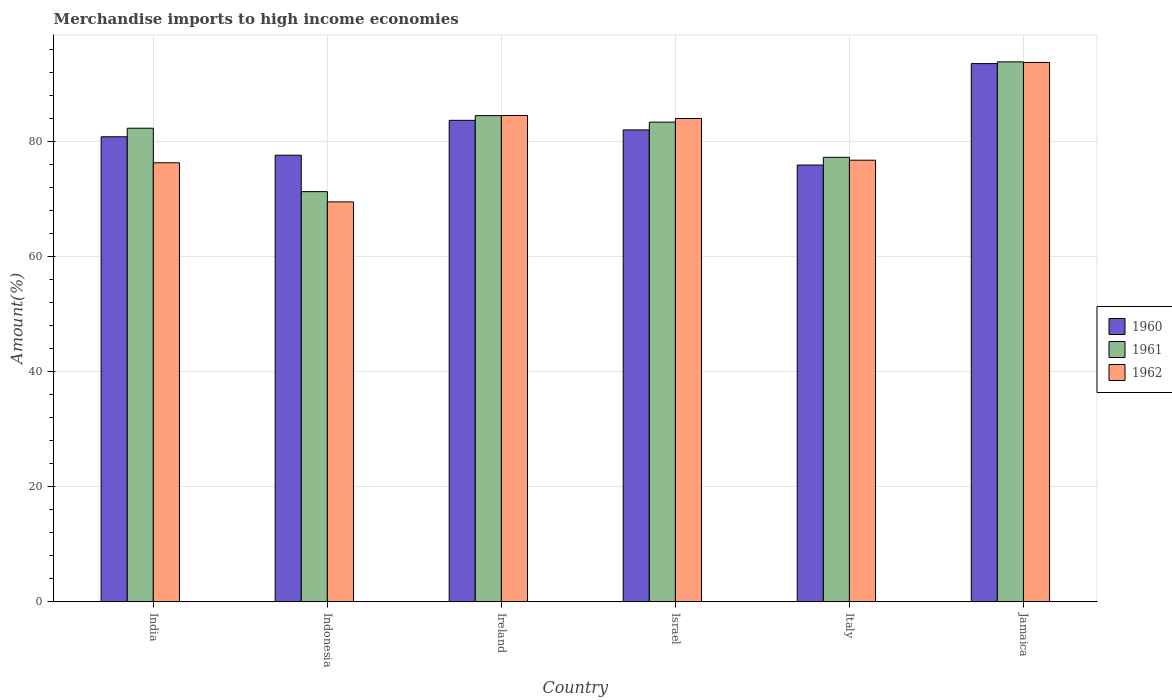How many different coloured bars are there?
Make the answer very short. 3. Are the number of bars per tick equal to the number of legend labels?
Ensure brevity in your answer.  Yes. How many bars are there on the 4th tick from the left?
Ensure brevity in your answer.  3. How many bars are there on the 4th tick from the right?
Offer a terse response. 3. What is the label of the 3rd group of bars from the left?
Provide a succinct answer. Ireland. In how many cases, is the number of bars for a given country not equal to the number of legend labels?
Ensure brevity in your answer.  0. What is the percentage of amount earned from merchandise imports in 1962 in Ireland?
Offer a terse response. 84.51. Across all countries, what is the maximum percentage of amount earned from merchandise imports in 1962?
Your answer should be compact. 93.72. Across all countries, what is the minimum percentage of amount earned from merchandise imports in 1960?
Your answer should be very brief. 75.9. In which country was the percentage of amount earned from merchandise imports in 1962 maximum?
Offer a terse response. Jamaica. What is the total percentage of amount earned from merchandise imports in 1961 in the graph?
Your response must be concise. 492.46. What is the difference between the percentage of amount earned from merchandise imports in 1960 in Israel and that in Italy?
Make the answer very short. 6.1. What is the difference between the percentage of amount earned from merchandise imports in 1962 in India and the percentage of amount earned from merchandise imports in 1960 in Jamaica?
Your response must be concise. -17.23. What is the average percentage of amount earned from merchandise imports in 1961 per country?
Provide a short and direct response. 82.08. What is the difference between the percentage of amount earned from merchandise imports of/in 1961 and percentage of amount earned from merchandise imports of/in 1962 in India?
Your response must be concise. 6. What is the ratio of the percentage of amount earned from merchandise imports in 1961 in Indonesia to that in Italy?
Provide a succinct answer. 0.92. What is the difference between the highest and the second highest percentage of amount earned from merchandise imports in 1962?
Offer a terse response. -0.52. What is the difference between the highest and the lowest percentage of amount earned from merchandise imports in 1962?
Offer a terse response. 24.22. In how many countries, is the percentage of amount earned from merchandise imports in 1960 greater than the average percentage of amount earned from merchandise imports in 1960 taken over all countries?
Offer a terse response. 2. Is the sum of the percentage of amount earned from merchandise imports in 1960 in India and Ireland greater than the maximum percentage of amount earned from merchandise imports in 1962 across all countries?
Your answer should be very brief. Yes. What does the 3rd bar from the left in Ireland represents?
Provide a short and direct response. 1962. What does the 3rd bar from the right in Indonesia represents?
Your answer should be very brief. 1960. How many countries are there in the graph?
Offer a very short reply. 6. Where does the legend appear in the graph?
Your answer should be compact. Center right. What is the title of the graph?
Keep it short and to the point. Merchandise imports to high income economies. Does "1972" appear as one of the legend labels in the graph?
Make the answer very short. No. What is the label or title of the Y-axis?
Keep it short and to the point. Amount(%). What is the Amount(%) of 1960 in India?
Your answer should be very brief. 80.81. What is the Amount(%) in 1961 in India?
Provide a succinct answer. 82.29. What is the Amount(%) of 1962 in India?
Make the answer very short. 76.29. What is the Amount(%) in 1960 in Indonesia?
Your answer should be compact. 77.61. What is the Amount(%) of 1961 in Indonesia?
Provide a short and direct response. 71.28. What is the Amount(%) of 1962 in Indonesia?
Make the answer very short. 69.5. What is the Amount(%) in 1960 in Ireland?
Make the answer very short. 83.66. What is the Amount(%) in 1961 in Ireland?
Offer a terse response. 84.48. What is the Amount(%) in 1962 in Ireland?
Provide a short and direct response. 84.51. What is the Amount(%) in 1960 in Israel?
Give a very brief answer. 82. What is the Amount(%) in 1961 in Israel?
Provide a short and direct response. 83.35. What is the Amount(%) of 1962 in Israel?
Provide a short and direct response. 83.98. What is the Amount(%) of 1960 in Italy?
Offer a terse response. 75.9. What is the Amount(%) in 1961 in Italy?
Offer a terse response. 77.24. What is the Amount(%) in 1962 in Italy?
Your answer should be very brief. 76.74. What is the Amount(%) in 1960 in Jamaica?
Your answer should be compact. 93.52. What is the Amount(%) of 1961 in Jamaica?
Your answer should be very brief. 93.82. What is the Amount(%) in 1962 in Jamaica?
Provide a succinct answer. 93.72. Across all countries, what is the maximum Amount(%) of 1960?
Keep it short and to the point. 93.52. Across all countries, what is the maximum Amount(%) of 1961?
Keep it short and to the point. 93.82. Across all countries, what is the maximum Amount(%) of 1962?
Provide a short and direct response. 93.72. Across all countries, what is the minimum Amount(%) of 1960?
Your answer should be very brief. 75.9. Across all countries, what is the minimum Amount(%) in 1961?
Your answer should be compact. 71.28. Across all countries, what is the minimum Amount(%) of 1962?
Your answer should be compact. 69.5. What is the total Amount(%) of 1960 in the graph?
Make the answer very short. 493.5. What is the total Amount(%) of 1961 in the graph?
Ensure brevity in your answer.  492.46. What is the total Amount(%) in 1962 in the graph?
Give a very brief answer. 484.74. What is the difference between the Amount(%) in 1960 in India and that in Indonesia?
Your answer should be very brief. 3.2. What is the difference between the Amount(%) of 1961 in India and that in Indonesia?
Make the answer very short. 11.02. What is the difference between the Amount(%) in 1962 in India and that in Indonesia?
Provide a short and direct response. 6.8. What is the difference between the Amount(%) of 1960 in India and that in Ireland?
Give a very brief answer. -2.86. What is the difference between the Amount(%) in 1961 in India and that in Ireland?
Make the answer very short. -2.19. What is the difference between the Amount(%) of 1962 in India and that in Ireland?
Offer a terse response. -8.21. What is the difference between the Amount(%) in 1960 in India and that in Israel?
Your answer should be compact. -1.19. What is the difference between the Amount(%) of 1961 in India and that in Israel?
Provide a short and direct response. -1.05. What is the difference between the Amount(%) of 1962 in India and that in Israel?
Your response must be concise. -7.69. What is the difference between the Amount(%) of 1960 in India and that in Italy?
Offer a very short reply. 4.91. What is the difference between the Amount(%) of 1961 in India and that in Italy?
Provide a succinct answer. 5.06. What is the difference between the Amount(%) of 1962 in India and that in Italy?
Your answer should be very brief. -0.45. What is the difference between the Amount(%) of 1960 in India and that in Jamaica?
Your answer should be compact. -12.71. What is the difference between the Amount(%) in 1961 in India and that in Jamaica?
Give a very brief answer. -11.53. What is the difference between the Amount(%) in 1962 in India and that in Jamaica?
Your answer should be very brief. -17.43. What is the difference between the Amount(%) of 1960 in Indonesia and that in Ireland?
Ensure brevity in your answer.  -6.06. What is the difference between the Amount(%) of 1961 in Indonesia and that in Ireland?
Provide a short and direct response. -13.21. What is the difference between the Amount(%) of 1962 in Indonesia and that in Ireland?
Your answer should be very brief. -15.01. What is the difference between the Amount(%) in 1960 in Indonesia and that in Israel?
Provide a short and direct response. -4.39. What is the difference between the Amount(%) in 1961 in Indonesia and that in Israel?
Your answer should be compact. -12.07. What is the difference between the Amount(%) of 1962 in Indonesia and that in Israel?
Keep it short and to the point. -14.48. What is the difference between the Amount(%) in 1960 in Indonesia and that in Italy?
Provide a short and direct response. 1.71. What is the difference between the Amount(%) in 1961 in Indonesia and that in Italy?
Offer a very short reply. -5.96. What is the difference between the Amount(%) in 1962 in Indonesia and that in Italy?
Offer a terse response. -7.24. What is the difference between the Amount(%) in 1960 in Indonesia and that in Jamaica?
Your answer should be compact. -15.92. What is the difference between the Amount(%) in 1961 in Indonesia and that in Jamaica?
Offer a very short reply. -22.55. What is the difference between the Amount(%) of 1962 in Indonesia and that in Jamaica?
Make the answer very short. -24.22. What is the difference between the Amount(%) of 1960 in Ireland and that in Israel?
Your response must be concise. 1.66. What is the difference between the Amount(%) in 1961 in Ireland and that in Israel?
Your answer should be compact. 1.13. What is the difference between the Amount(%) of 1962 in Ireland and that in Israel?
Offer a very short reply. 0.52. What is the difference between the Amount(%) of 1960 in Ireland and that in Italy?
Provide a succinct answer. 7.77. What is the difference between the Amount(%) of 1961 in Ireland and that in Italy?
Offer a terse response. 7.24. What is the difference between the Amount(%) of 1962 in Ireland and that in Italy?
Keep it short and to the point. 7.77. What is the difference between the Amount(%) of 1960 in Ireland and that in Jamaica?
Give a very brief answer. -9.86. What is the difference between the Amount(%) in 1961 in Ireland and that in Jamaica?
Give a very brief answer. -9.34. What is the difference between the Amount(%) in 1962 in Ireland and that in Jamaica?
Keep it short and to the point. -9.21. What is the difference between the Amount(%) of 1960 in Israel and that in Italy?
Ensure brevity in your answer.  6.1. What is the difference between the Amount(%) of 1961 in Israel and that in Italy?
Your answer should be compact. 6.11. What is the difference between the Amount(%) of 1962 in Israel and that in Italy?
Ensure brevity in your answer.  7.24. What is the difference between the Amount(%) of 1960 in Israel and that in Jamaica?
Give a very brief answer. -11.52. What is the difference between the Amount(%) of 1961 in Israel and that in Jamaica?
Your response must be concise. -10.47. What is the difference between the Amount(%) in 1962 in Israel and that in Jamaica?
Ensure brevity in your answer.  -9.74. What is the difference between the Amount(%) in 1960 in Italy and that in Jamaica?
Provide a short and direct response. -17.62. What is the difference between the Amount(%) in 1961 in Italy and that in Jamaica?
Your answer should be compact. -16.58. What is the difference between the Amount(%) in 1962 in Italy and that in Jamaica?
Offer a very short reply. -16.98. What is the difference between the Amount(%) in 1960 in India and the Amount(%) in 1961 in Indonesia?
Keep it short and to the point. 9.53. What is the difference between the Amount(%) of 1960 in India and the Amount(%) of 1962 in Indonesia?
Provide a succinct answer. 11.31. What is the difference between the Amount(%) of 1961 in India and the Amount(%) of 1962 in Indonesia?
Your answer should be compact. 12.8. What is the difference between the Amount(%) of 1960 in India and the Amount(%) of 1961 in Ireland?
Make the answer very short. -3.67. What is the difference between the Amount(%) of 1960 in India and the Amount(%) of 1962 in Ireland?
Offer a very short reply. -3.7. What is the difference between the Amount(%) of 1961 in India and the Amount(%) of 1962 in Ireland?
Offer a very short reply. -2.21. What is the difference between the Amount(%) of 1960 in India and the Amount(%) of 1961 in Israel?
Your response must be concise. -2.54. What is the difference between the Amount(%) in 1960 in India and the Amount(%) in 1962 in Israel?
Your response must be concise. -3.17. What is the difference between the Amount(%) of 1961 in India and the Amount(%) of 1962 in Israel?
Provide a short and direct response. -1.69. What is the difference between the Amount(%) in 1960 in India and the Amount(%) in 1961 in Italy?
Offer a terse response. 3.57. What is the difference between the Amount(%) of 1960 in India and the Amount(%) of 1962 in Italy?
Make the answer very short. 4.07. What is the difference between the Amount(%) of 1961 in India and the Amount(%) of 1962 in Italy?
Make the answer very short. 5.55. What is the difference between the Amount(%) of 1960 in India and the Amount(%) of 1961 in Jamaica?
Make the answer very short. -13.01. What is the difference between the Amount(%) of 1960 in India and the Amount(%) of 1962 in Jamaica?
Your answer should be compact. -12.91. What is the difference between the Amount(%) of 1961 in India and the Amount(%) of 1962 in Jamaica?
Provide a short and direct response. -11.43. What is the difference between the Amount(%) of 1960 in Indonesia and the Amount(%) of 1961 in Ireland?
Make the answer very short. -6.88. What is the difference between the Amount(%) in 1960 in Indonesia and the Amount(%) in 1962 in Ireland?
Your answer should be very brief. -6.9. What is the difference between the Amount(%) of 1961 in Indonesia and the Amount(%) of 1962 in Ireland?
Give a very brief answer. -13.23. What is the difference between the Amount(%) in 1960 in Indonesia and the Amount(%) in 1961 in Israel?
Your answer should be very brief. -5.74. What is the difference between the Amount(%) in 1960 in Indonesia and the Amount(%) in 1962 in Israel?
Keep it short and to the point. -6.38. What is the difference between the Amount(%) in 1961 in Indonesia and the Amount(%) in 1962 in Israel?
Your answer should be very brief. -12.71. What is the difference between the Amount(%) of 1960 in Indonesia and the Amount(%) of 1961 in Italy?
Your answer should be very brief. 0.37. What is the difference between the Amount(%) in 1960 in Indonesia and the Amount(%) in 1962 in Italy?
Provide a succinct answer. 0.87. What is the difference between the Amount(%) of 1961 in Indonesia and the Amount(%) of 1962 in Italy?
Keep it short and to the point. -5.46. What is the difference between the Amount(%) in 1960 in Indonesia and the Amount(%) in 1961 in Jamaica?
Your response must be concise. -16.22. What is the difference between the Amount(%) in 1960 in Indonesia and the Amount(%) in 1962 in Jamaica?
Ensure brevity in your answer.  -16.11. What is the difference between the Amount(%) in 1961 in Indonesia and the Amount(%) in 1962 in Jamaica?
Your response must be concise. -22.44. What is the difference between the Amount(%) of 1960 in Ireland and the Amount(%) of 1961 in Israel?
Provide a succinct answer. 0.32. What is the difference between the Amount(%) of 1960 in Ireland and the Amount(%) of 1962 in Israel?
Make the answer very short. -0.32. What is the difference between the Amount(%) of 1961 in Ireland and the Amount(%) of 1962 in Israel?
Ensure brevity in your answer.  0.5. What is the difference between the Amount(%) of 1960 in Ireland and the Amount(%) of 1961 in Italy?
Provide a succinct answer. 6.43. What is the difference between the Amount(%) of 1960 in Ireland and the Amount(%) of 1962 in Italy?
Your answer should be compact. 6.92. What is the difference between the Amount(%) of 1961 in Ireland and the Amount(%) of 1962 in Italy?
Ensure brevity in your answer.  7.74. What is the difference between the Amount(%) of 1960 in Ireland and the Amount(%) of 1961 in Jamaica?
Offer a terse response. -10.16. What is the difference between the Amount(%) in 1960 in Ireland and the Amount(%) in 1962 in Jamaica?
Make the answer very short. -10.06. What is the difference between the Amount(%) in 1961 in Ireland and the Amount(%) in 1962 in Jamaica?
Give a very brief answer. -9.24. What is the difference between the Amount(%) in 1960 in Israel and the Amount(%) in 1961 in Italy?
Provide a succinct answer. 4.76. What is the difference between the Amount(%) of 1960 in Israel and the Amount(%) of 1962 in Italy?
Ensure brevity in your answer.  5.26. What is the difference between the Amount(%) of 1961 in Israel and the Amount(%) of 1962 in Italy?
Ensure brevity in your answer.  6.61. What is the difference between the Amount(%) of 1960 in Israel and the Amount(%) of 1961 in Jamaica?
Provide a short and direct response. -11.82. What is the difference between the Amount(%) in 1960 in Israel and the Amount(%) in 1962 in Jamaica?
Your response must be concise. -11.72. What is the difference between the Amount(%) of 1961 in Israel and the Amount(%) of 1962 in Jamaica?
Your answer should be very brief. -10.37. What is the difference between the Amount(%) in 1960 in Italy and the Amount(%) in 1961 in Jamaica?
Ensure brevity in your answer.  -17.92. What is the difference between the Amount(%) of 1960 in Italy and the Amount(%) of 1962 in Jamaica?
Keep it short and to the point. -17.82. What is the difference between the Amount(%) of 1961 in Italy and the Amount(%) of 1962 in Jamaica?
Provide a short and direct response. -16.48. What is the average Amount(%) of 1960 per country?
Make the answer very short. 82.25. What is the average Amount(%) of 1961 per country?
Your answer should be compact. 82.08. What is the average Amount(%) in 1962 per country?
Your answer should be very brief. 80.79. What is the difference between the Amount(%) of 1960 and Amount(%) of 1961 in India?
Your answer should be compact. -1.49. What is the difference between the Amount(%) of 1960 and Amount(%) of 1962 in India?
Offer a very short reply. 4.51. What is the difference between the Amount(%) of 1961 and Amount(%) of 1962 in India?
Your response must be concise. 6. What is the difference between the Amount(%) of 1960 and Amount(%) of 1961 in Indonesia?
Offer a terse response. 6.33. What is the difference between the Amount(%) of 1960 and Amount(%) of 1962 in Indonesia?
Your response must be concise. 8.11. What is the difference between the Amount(%) in 1961 and Amount(%) in 1962 in Indonesia?
Provide a succinct answer. 1.78. What is the difference between the Amount(%) in 1960 and Amount(%) in 1961 in Ireland?
Offer a very short reply. -0.82. What is the difference between the Amount(%) of 1960 and Amount(%) of 1962 in Ireland?
Your answer should be compact. -0.84. What is the difference between the Amount(%) of 1961 and Amount(%) of 1962 in Ireland?
Offer a very short reply. -0.02. What is the difference between the Amount(%) in 1960 and Amount(%) in 1961 in Israel?
Your response must be concise. -1.35. What is the difference between the Amount(%) in 1960 and Amount(%) in 1962 in Israel?
Provide a succinct answer. -1.98. What is the difference between the Amount(%) of 1961 and Amount(%) of 1962 in Israel?
Your response must be concise. -0.63. What is the difference between the Amount(%) in 1960 and Amount(%) in 1961 in Italy?
Provide a succinct answer. -1.34. What is the difference between the Amount(%) in 1960 and Amount(%) in 1962 in Italy?
Your answer should be very brief. -0.84. What is the difference between the Amount(%) in 1961 and Amount(%) in 1962 in Italy?
Offer a terse response. 0.5. What is the difference between the Amount(%) in 1960 and Amount(%) in 1961 in Jamaica?
Your answer should be very brief. -0.3. What is the difference between the Amount(%) of 1960 and Amount(%) of 1962 in Jamaica?
Make the answer very short. -0.2. What is the difference between the Amount(%) in 1961 and Amount(%) in 1962 in Jamaica?
Provide a short and direct response. 0.1. What is the ratio of the Amount(%) of 1960 in India to that in Indonesia?
Keep it short and to the point. 1.04. What is the ratio of the Amount(%) in 1961 in India to that in Indonesia?
Ensure brevity in your answer.  1.15. What is the ratio of the Amount(%) in 1962 in India to that in Indonesia?
Keep it short and to the point. 1.1. What is the ratio of the Amount(%) of 1960 in India to that in Ireland?
Offer a terse response. 0.97. What is the ratio of the Amount(%) in 1961 in India to that in Ireland?
Provide a short and direct response. 0.97. What is the ratio of the Amount(%) of 1962 in India to that in Ireland?
Your answer should be compact. 0.9. What is the ratio of the Amount(%) of 1960 in India to that in Israel?
Make the answer very short. 0.99. What is the ratio of the Amount(%) of 1961 in India to that in Israel?
Your answer should be very brief. 0.99. What is the ratio of the Amount(%) in 1962 in India to that in Israel?
Provide a succinct answer. 0.91. What is the ratio of the Amount(%) in 1960 in India to that in Italy?
Your answer should be compact. 1.06. What is the ratio of the Amount(%) in 1961 in India to that in Italy?
Make the answer very short. 1.07. What is the ratio of the Amount(%) in 1962 in India to that in Italy?
Offer a very short reply. 0.99. What is the ratio of the Amount(%) of 1960 in India to that in Jamaica?
Your answer should be compact. 0.86. What is the ratio of the Amount(%) of 1961 in India to that in Jamaica?
Provide a short and direct response. 0.88. What is the ratio of the Amount(%) of 1962 in India to that in Jamaica?
Give a very brief answer. 0.81. What is the ratio of the Amount(%) in 1960 in Indonesia to that in Ireland?
Your answer should be compact. 0.93. What is the ratio of the Amount(%) in 1961 in Indonesia to that in Ireland?
Provide a short and direct response. 0.84. What is the ratio of the Amount(%) of 1962 in Indonesia to that in Ireland?
Make the answer very short. 0.82. What is the ratio of the Amount(%) of 1960 in Indonesia to that in Israel?
Ensure brevity in your answer.  0.95. What is the ratio of the Amount(%) of 1961 in Indonesia to that in Israel?
Your answer should be compact. 0.86. What is the ratio of the Amount(%) in 1962 in Indonesia to that in Israel?
Give a very brief answer. 0.83. What is the ratio of the Amount(%) in 1960 in Indonesia to that in Italy?
Provide a short and direct response. 1.02. What is the ratio of the Amount(%) in 1961 in Indonesia to that in Italy?
Give a very brief answer. 0.92. What is the ratio of the Amount(%) of 1962 in Indonesia to that in Italy?
Provide a short and direct response. 0.91. What is the ratio of the Amount(%) in 1960 in Indonesia to that in Jamaica?
Make the answer very short. 0.83. What is the ratio of the Amount(%) of 1961 in Indonesia to that in Jamaica?
Your answer should be compact. 0.76. What is the ratio of the Amount(%) of 1962 in Indonesia to that in Jamaica?
Provide a succinct answer. 0.74. What is the ratio of the Amount(%) in 1960 in Ireland to that in Israel?
Your answer should be compact. 1.02. What is the ratio of the Amount(%) in 1961 in Ireland to that in Israel?
Give a very brief answer. 1.01. What is the ratio of the Amount(%) in 1962 in Ireland to that in Israel?
Make the answer very short. 1.01. What is the ratio of the Amount(%) in 1960 in Ireland to that in Italy?
Offer a very short reply. 1.1. What is the ratio of the Amount(%) of 1961 in Ireland to that in Italy?
Give a very brief answer. 1.09. What is the ratio of the Amount(%) of 1962 in Ireland to that in Italy?
Ensure brevity in your answer.  1.1. What is the ratio of the Amount(%) in 1960 in Ireland to that in Jamaica?
Your answer should be compact. 0.89. What is the ratio of the Amount(%) of 1961 in Ireland to that in Jamaica?
Your answer should be very brief. 0.9. What is the ratio of the Amount(%) of 1962 in Ireland to that in Jamaica?
Offer a very short reply. 0.9. What is the ratio of the Amount(%) in 1960 in Israel to that in Italy?
Your response must be concise. 1.08. What is the ratio of the Amount(%) in 1961 in Israel to that in Italy?
Provide a short and direct response. 1.08. What is the ratio of the Amount(%) of 1962 in Israel to that in Italy?
Your answer should be compact. 1.09. What is the ratio of the Amount(%) in 1960 in Israel to that in Jamaica?
Make the answer very short. 0.88. What is the ratio of the Amount(%) of 1961 in Israel to that in Jamaica?
Ensure brevity in your answer.  0.89. What is the ratio of the Amount(%) in 1962 in Israel to that in Jamaica?
Provide a succinct answer. 0.9. What is the ratio of the Amount(%) of 1960 in Italy to that in Jamaica?
Offer a terse response. 0.81. What is the ratio of the Amount(%) of 1961 in Italy to that in Jamaica?
Make the answer very short. 0.82. What is the ratio of the Amount(%) in 1962 in Italy to that in Jamaica?
Offer a very short reply. 0.82. What is the difference between the highest and the second highest Amount(%) in 1960?
Your answer should be compact. 9.86. What is the difference between the highest and the second highest Amount(%) of 1961?
Your answer should be very brief. 9.34. What is the difference between the highest and the second highest Amount(%) of 1962?
Ensure brevity in your answer.  9.21. What is the difference between the highest and the lowest Amount(%) in 1960?
Keep it short and to the point. 17.62. What is the difference between the highest and the lowest Amount(%) of 1961?
Your answer should be compact. 22.55. What is the difference between the highest and the lowest Amount(%) in 1962?
Your response must be concise. 24.22. 